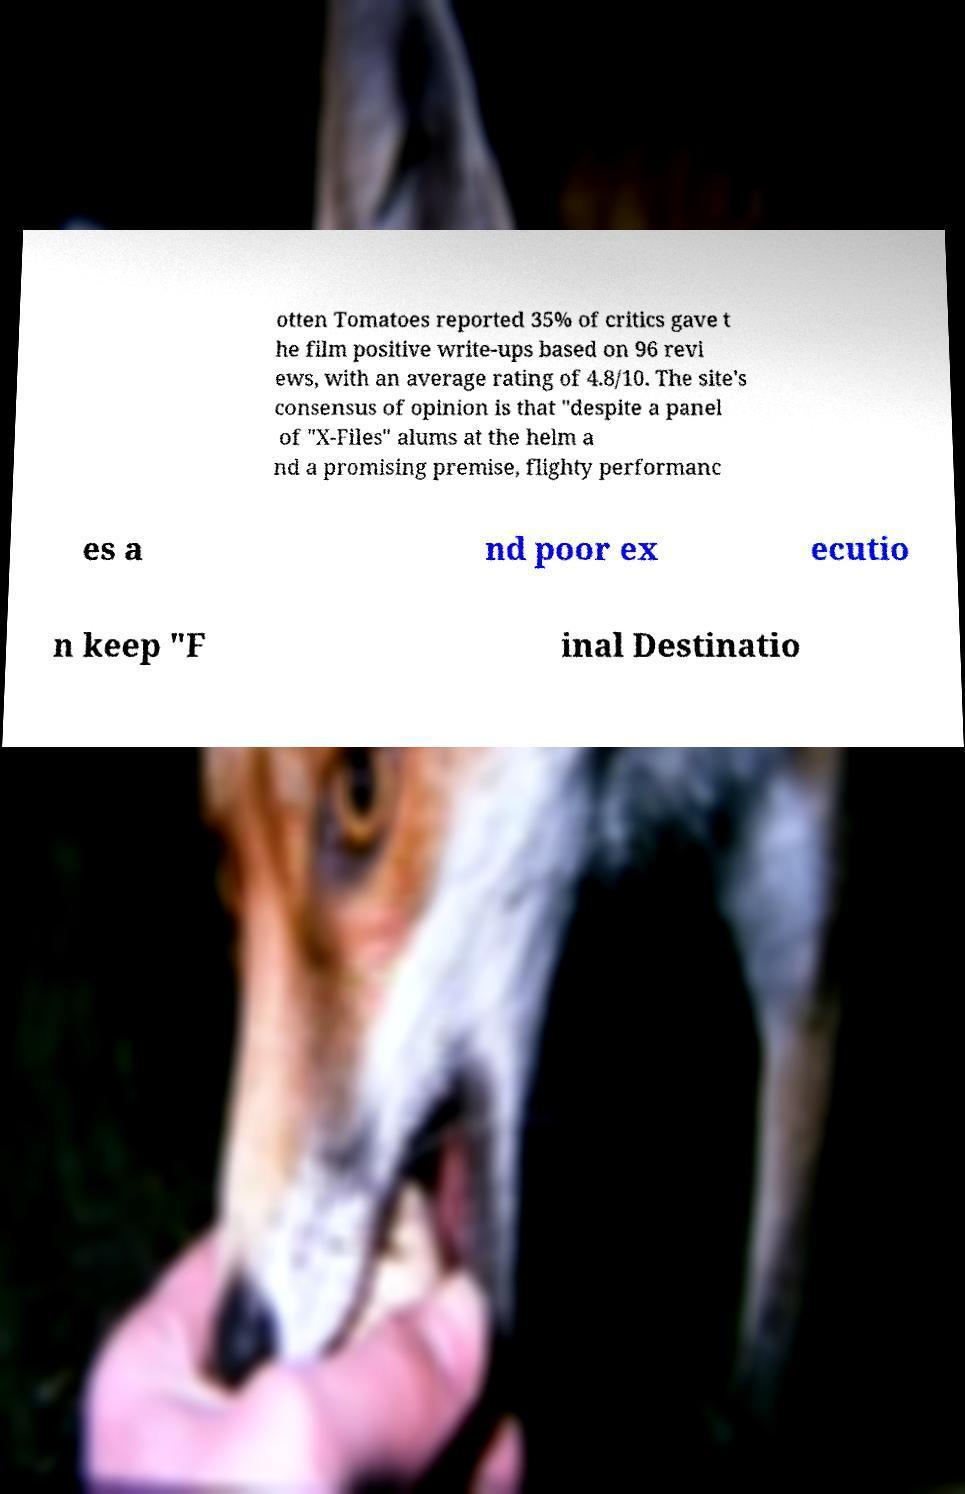Can you read and provide the text displayed in the image?This photo seems to have some interesting text. Can you extract and type it out for me? otten Tomatoes reported 35% of critics gave t he film positive write-ups based on 96 revi ews, with an average rating of 4.8/10. The site's consensus of opinion is that "despite a panel of "X-Files" alums at the helm a nd a promising premise, flighty performanc es a nd poor ex ecutio n keep "F inal Destinatio 